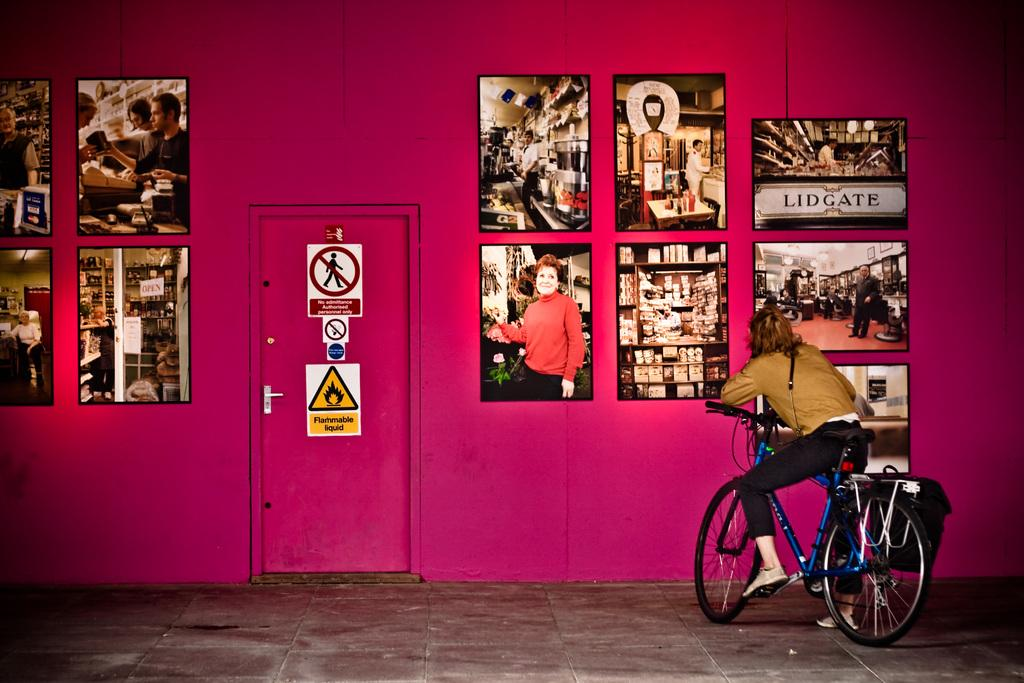What is the main subject of the image? There is a person on a bicycle in the image. What can be seen near the door in the image? There are signs near a door in the image. What is hanging on the wall in the image? There are frames on the wall in the image. Can you tell me how many goldfish are swimming in the frames on the wall? There are no goldfish present in the image; the frames on the wall contain something else or are empty. 